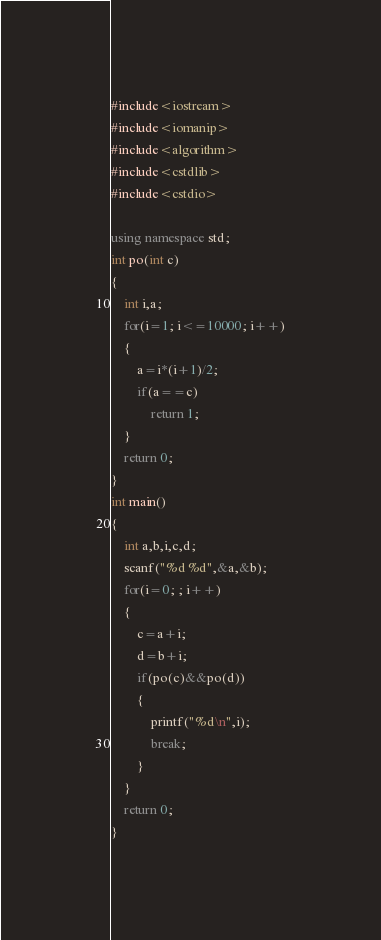Convert code to text. <code><loc_0><loc_0><loc_500><loc_500><_C++_>#include<iostream>
#include<iomanip>
#include<algorithm>
#include<cstdlib>
#include<cstdio>

using namespace std;
int po(int c)
{
    int i,a;
    for(i=1; i<=10000; i++)
    {
        a=i*(i+1)/2;
        if(a==c)
            return 1;
    }
    return 0;
}
int main()
{
    int a,b,i,c,d;
    scanf("%d %d",&a,&b);
    for(i=0; ; i++)
    {
        c=a+i;
        d=b+i;
        if(po(c)&&po(d))
        {
            printf("%d\n",i);
            break;
        }
    }
    return 0;
}
</code> 